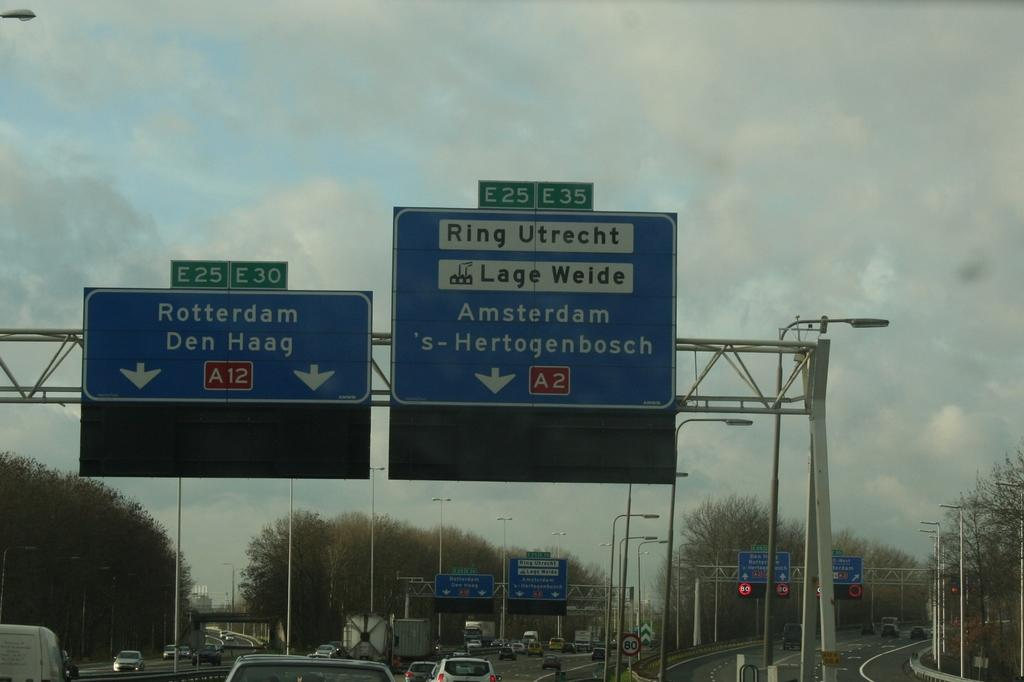<image>
Provide a brief description of the given image. Several street signs point to Rotterdam and Den Haag. 